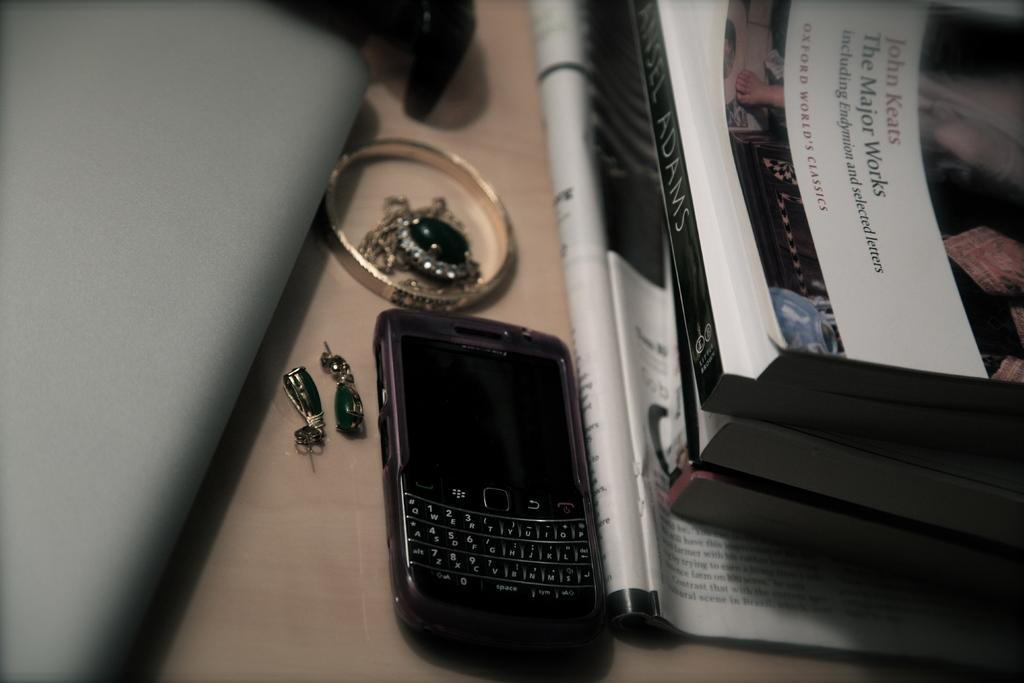<image>
Provide a brief description of the given image. The book beside the blackberry phone advertised Oxford World's classics. 